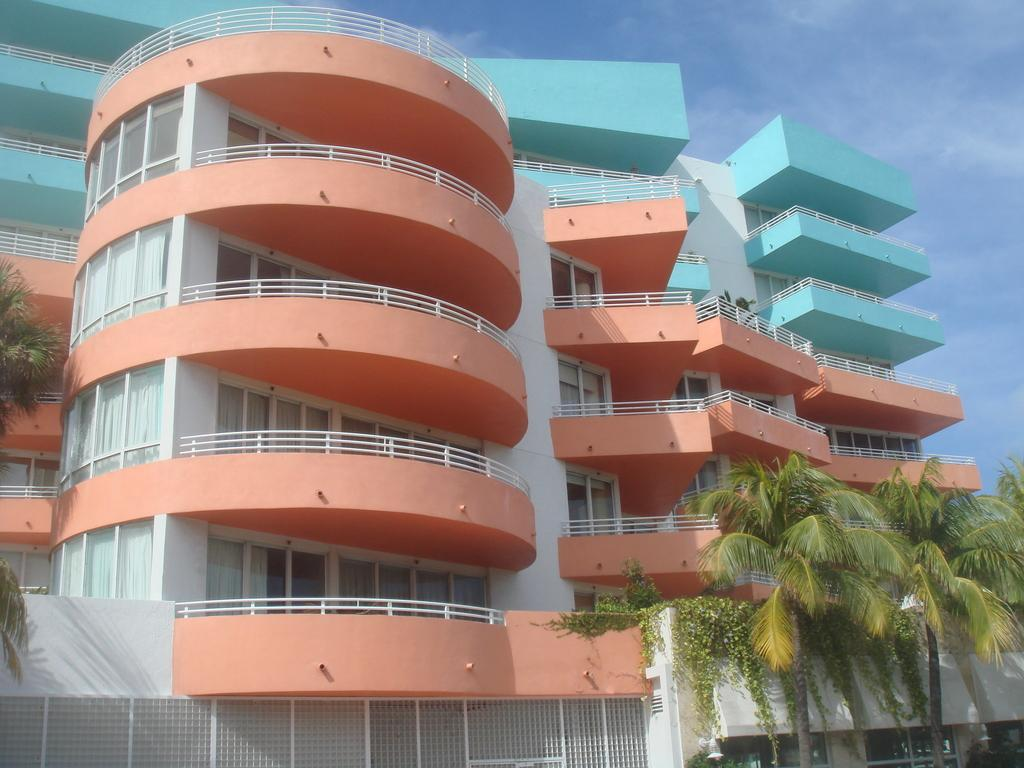What type of structure can be seen in the image? There is a building in the image. What tools are near the building? Drills are present near the building. What type of barrier is visible in the image? There is fencing in the image. What type of vegetation is present in the image? Trees and plants are visible in the image. What part of the natural environment is visible in the image? The sky is visible in the image. What can be seen in the sky? Clouds are present in the sky. What type of silverware is being used to drink soda in the image? There is no silverware or soda present in the image. 